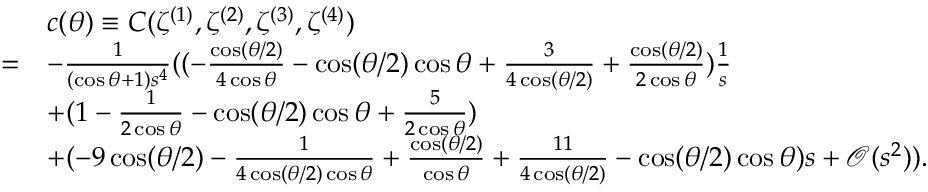<formula> <loc_0><loc_0><loc_500><loc_500>\begin{array} { r l } & { c ( \theta ) \equiv C ( \zeta ^ { ( 1 ) } , \zeta ^ { ( 2 ) } , \zeta ^ { ( 3 ) } , \zeta ^ { ( 4 ) } ) } \\ { = } & { - \frac { 1 } { ( \cos \theta + 1 ) s ^ { 4 } } ( ( - \frac { \cos ( { \theta } / { 2 } ) } { 4 \cos \theta } - \cos ( { \theta } / { 2 } ) \cos \theta + \frac { 3 } { 4 \cos ( { \theta } / { 2 } ) } + \frac { \cos ( { \theta } / { 2 } ) } { 2 \cos \theta } ) \frac { 1 } { s } } \\ & { + ( 1 - \frac { 1 } { 2 \cos \theta } - \cos ( { \theta } / { 2 } ) \cos \theta + \frac { 5 } { 2 \cos \theta } ) } \\ & { + ( - 9 \cos ( { \theta } / { 2 } ) - \frac { 1 } { 4 \cos ( { \theta } / { 2 } ) \cos \theta } + \frac { \cos ( { \theta } / { 2 } ) } { \cos \theta } + \frac { 1 1 } { 4 \cos ( { \theta } / { 2 } ) } - \cos ( { \theta } / { 2 } ) \cos \theta ) s + \mathcal { O } ( s ^ { 2 } ) ) . } \end{array}</formula> 